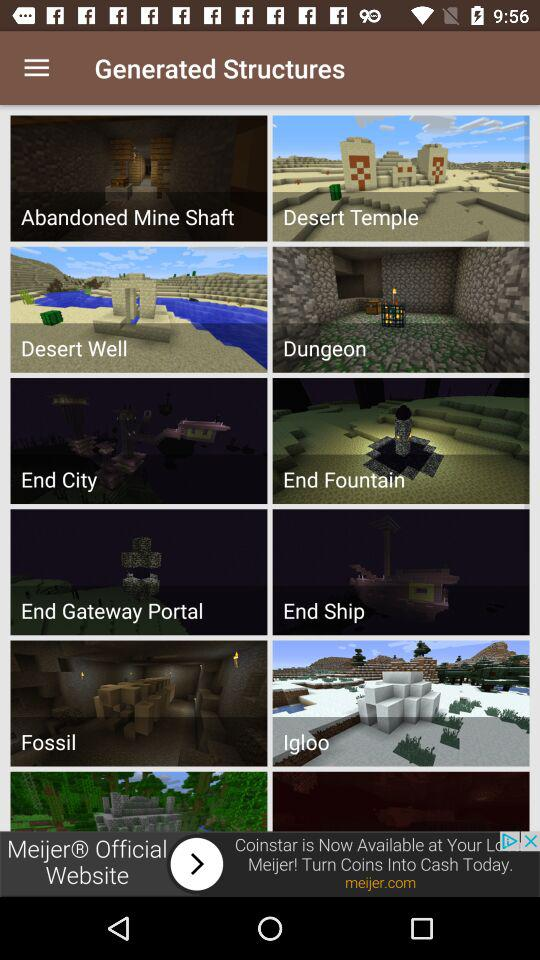What are the different generated structures? The different generated structures are "Abandoned Mine Shaft", "Desert Temple", "Desert Well", "Dungeon", "End City", "End Fountain", "End Gateway Portal", "End Ship", "Fossil" and "Igloo". 